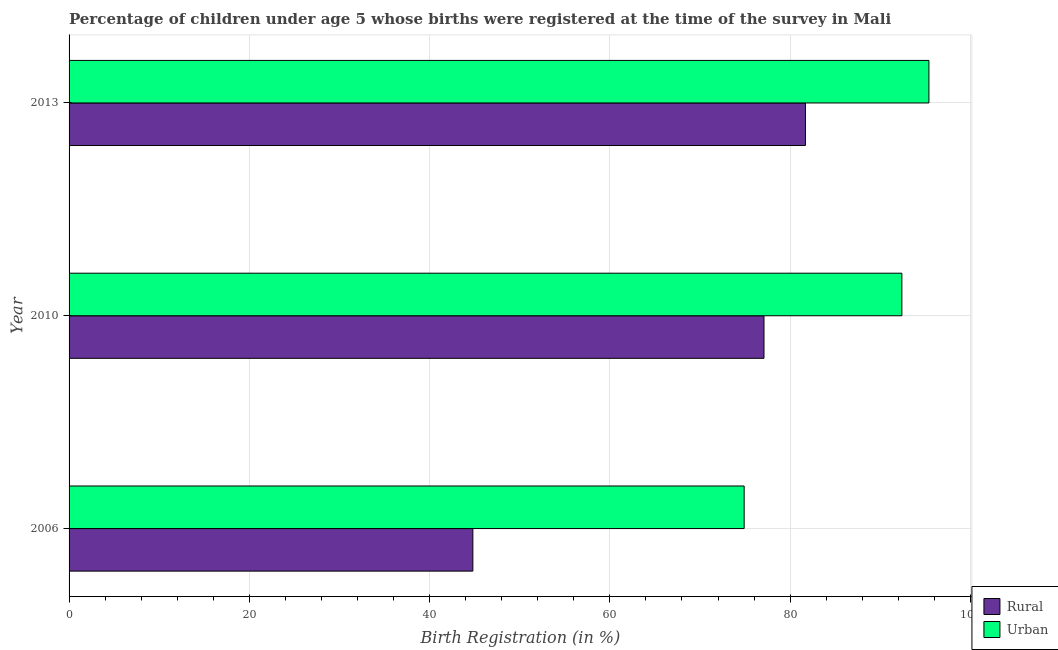Are the number of bars per tick equal to the number of legend labels?
Make the answer very short. Yes. Are the number of bars on each tick of the Y-axis equal?
Provide a short and direct response. Yes. How many bars are there on the 1st tick from the top?
Your answer should be very brief. 2. How many bars are there on the 1st tick from the bottom?
Your answer should be very brief. 2. What is the label of the 1st group of bars from the top?
Give a very brief answer. 2013. What is the urban birth registration in 2013?
Offer a terse response. 95.4. Across all years, what is the maximum rural birth registration?
Ensure brevity in your answer.  81.7. Across all years, what is the minimum rural birth registration?
Make the answer very short. 44.8. In which year was the urban birth registration minimum?
Provide a short and direct response. 2006. What is the total rural birth registration in the graph?
Your answer should be compact. 203.6. What is the difference between the urban birth registration in 2006 and that in 2010?
Keep it short and to the point. -17.5. What is the difference between the rural birth registration in 2006 and the urban birth registration in 2010?
Give a very brief answer. -47.6. What is the average rural birth registration per year?
Offer a terse response. 67.87. In the year 2006, what is the difference between the urban birth registration and rural birth registration?
Your response must be concise. 30.1. In how many years, is the rural birth registration greater than 88 %?
Your answer should be very brief. 0. What is the difference between the highest and the second highest rural birth registration?
Your answer should be very brief. 4.6. What is the difference between the highest and the lowest rural birth registration?
Ensure brevity in your answer.  36.9. Is the sum of the urban birth registration in 2006 and 2013 greater than the maximum rural birth registration across all years?
Provide a succinct answer. Yes. What does the 2nd bar from the top in 2010 represents?
Your answer should be compact. Rural. What does the 2nd bar from the bottom in 2010 represents?
Keep it short and to the point. Urban. How many years are there in the graph?
Your answer should be very brief. 3. What is the difference between two consecutive major ticks on the X-axis?
Provide a succinct answer. 20. Are the values on the major ticks of X-axis written in scientific E-notation?
Ensure brevity in your answer.  No. Does the graph contain any zero values?
Your response must be concise. No. How are the legend labels stacked?
Give a very brief answer. Vertical. What is the title of the graph?
Make the answer very short. Percentage of children under age 5 whose births were registered at the time of the survey in Mali. What is the label or title of the X-axis?
Your response must be concise. Birth Registration (in %). What is the label or title of the Y-axis?
Keep it short and to the point. Year. What is the Birth Registration (in %) in Rural in 2006?
Your response must be concise. 44.8. What is the Birth Registration (in %) in Urban in 2006?
Your response must be concise. 74.9. What is the Birth Registration (in %) in Rural in 2010?
Provide a succinct answer. 77.1. What is the Birth Registration (in %) in Urban in 2010?
Offer a very short reply. 92.4. What is the Birth Registration (in %) in Rural in 2013?
Provide a succinct answer. 81.7. What is the Birth Registration (in %) in Urban in 2013?
Ensure brevity in your answer.  95.4. Across all years, what is the maximum Birth Registration (in %) of Rural?
Provide a succinct answer. 81.7. Across all years, what is the maximum Birth Registration (in %) in Urban?
Your answer should be very brief. 95.4. Across all years, what is the minimum Birth Registration (in %) in Rural?
Provide a short and direct response. 44.8. Across all years, what is the minimum Birth Registration (in %) of Urban?
Offer a terse response. 74.9. What is the total Birth Registration (in %) in Rural in the graph?
Ensure brevity in your answer.  203.6. What is the total Birth Registration (in %) of Urban in the graph?
Offer a terse response. 262.7. What is the difference between the Birth Registration (in %) of Rural in 2006 and that in 2010?
Provide a short and direct response. -32.3. What is the difference between the Birth Registration (in %) of Urban in 2006 and that in 2010?
Make the answer very short. -17.5. What is the difference between the Birth Registration (in %) of Rural in 2006 and that in 2013?
Your answer should be very brief. -36.9. What is the difference between the Birth Registration (in %) in Urban in 2006 and that in 2013?
Give a very brief answer. -20.5. What is the difference between the Birth Registration (in %) in Urban in 2010 and that in 2013?
Keep it short and to the point. -3. What is the difference between the Birth Registration (in %) of Rural in 2006 and the Birth Registration (in %) of Urban in 2010?
Offer a very short reply. -47.6. What is the difference between the Birth Registration (in %) of Rural in 2006 and the Birth Registration (in %) of Urban in 2013?
Offer a very short reply. -50.6. What is the difference between the Birth Registration (in %) in Rural in 2010 and the Birth Registration (in %) in Urban in 2013?
Make the answer very short. -18.3. What is the average Birth Registration (in %) of Rural per year?
Your response must be concise. 67.87. What is the average Birth Registration (in %) in Urban per year?
Your answer should be compact. 87.57. In the year 2006, what is the difference between the Birth Registration (in %) of Rural and Birth Registration (in %) of Urban?
Provide a succinct answer. -30.1. In the year 2010, what is the difference between the Birth Registration (in %) of Rural and Birth Registration (in %) of Urban?
Your answer should be compact. -15.3. In the year 2013, what is the difference between the Birth Registration (in %) in Rural and Birth Registration (in %) in Urban?
Offer a terse response. -13.7. What is the ratio of the Birth Registration (in %) of Rural in 2006 to that in 2010?
Ensure brevity in your answer.  0.58. What is the ratio of the Birth Registration (in %) in Urban in 2006 to that in 2010?
Offer a terse response. 0.81. What is the ratio of the Birth Registration (in %) of Rural in 2006 to that in 2013?
Offer a terse response. 0.55. What is the ratio of the Birth Registration (in %) in Urban in 2006 to that in 2013?
Provide a short and direct response. 0.79. What is the ratio of the Birth Registration (in %) in Rural in 2010 to that in 2013?
Your answer should be compact. 0.94. What is the ratio of the Birth Registration (in %) of Urban in 2010 to that in 2013?
Offer a very short reply. 0.97. What is the difference between the highest and the second highest Birth Registration (in %) in Urban?
Ensure brevity in your answer.  3. What is the difference between the highest and the lowest Birth Registration (in %) of Rural?
Your answer should be very brief. 36.9. 